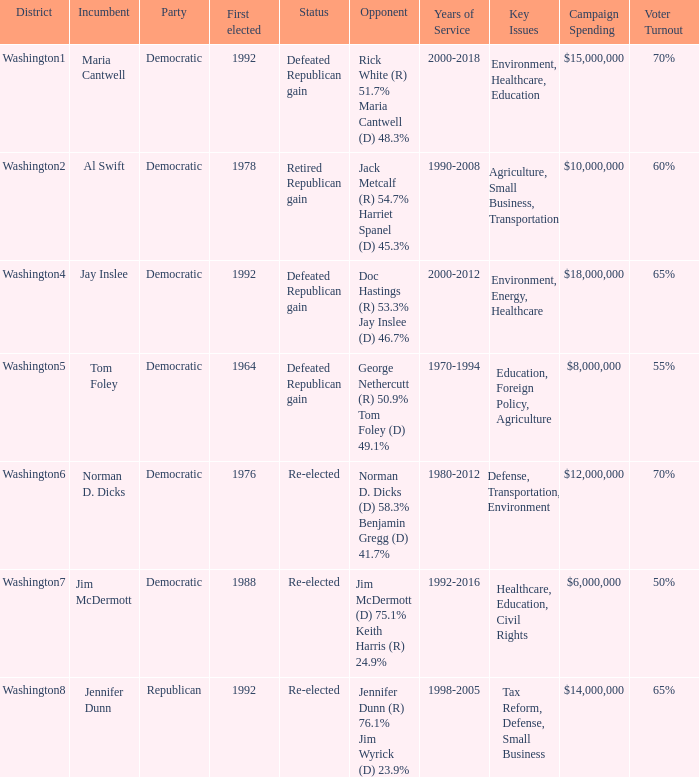In which year was jim mcdermott, the incumbent, initially elected? 1988.0. 